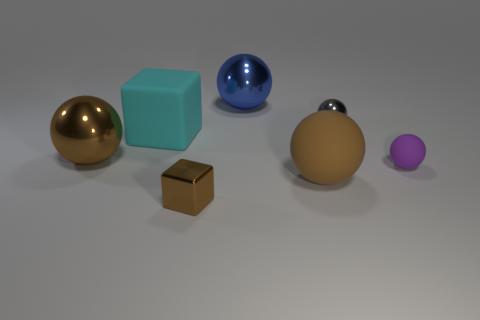Subtract all blue balls. How many balls are left? 4 Subtract all small matte spheres. How many spheres are left? 4 Subtract all blue balls. Subtract all gray cylinders. How many balls are left? 4 Add 1 large matte spheres. How many objects exist? 8 Subtract all blocks. How many objects are left? 5 Add 3 brown shiny objects. How many brown shiny objects exist? 5 Subtract 0 red balls. How many objects are left? 7 Subtract all tiny blue metallic cylinders. Subtract all tiny purple spheres. How many objects are left? 6 Add 5 big blue balls. How many big blue balls are left? 6 